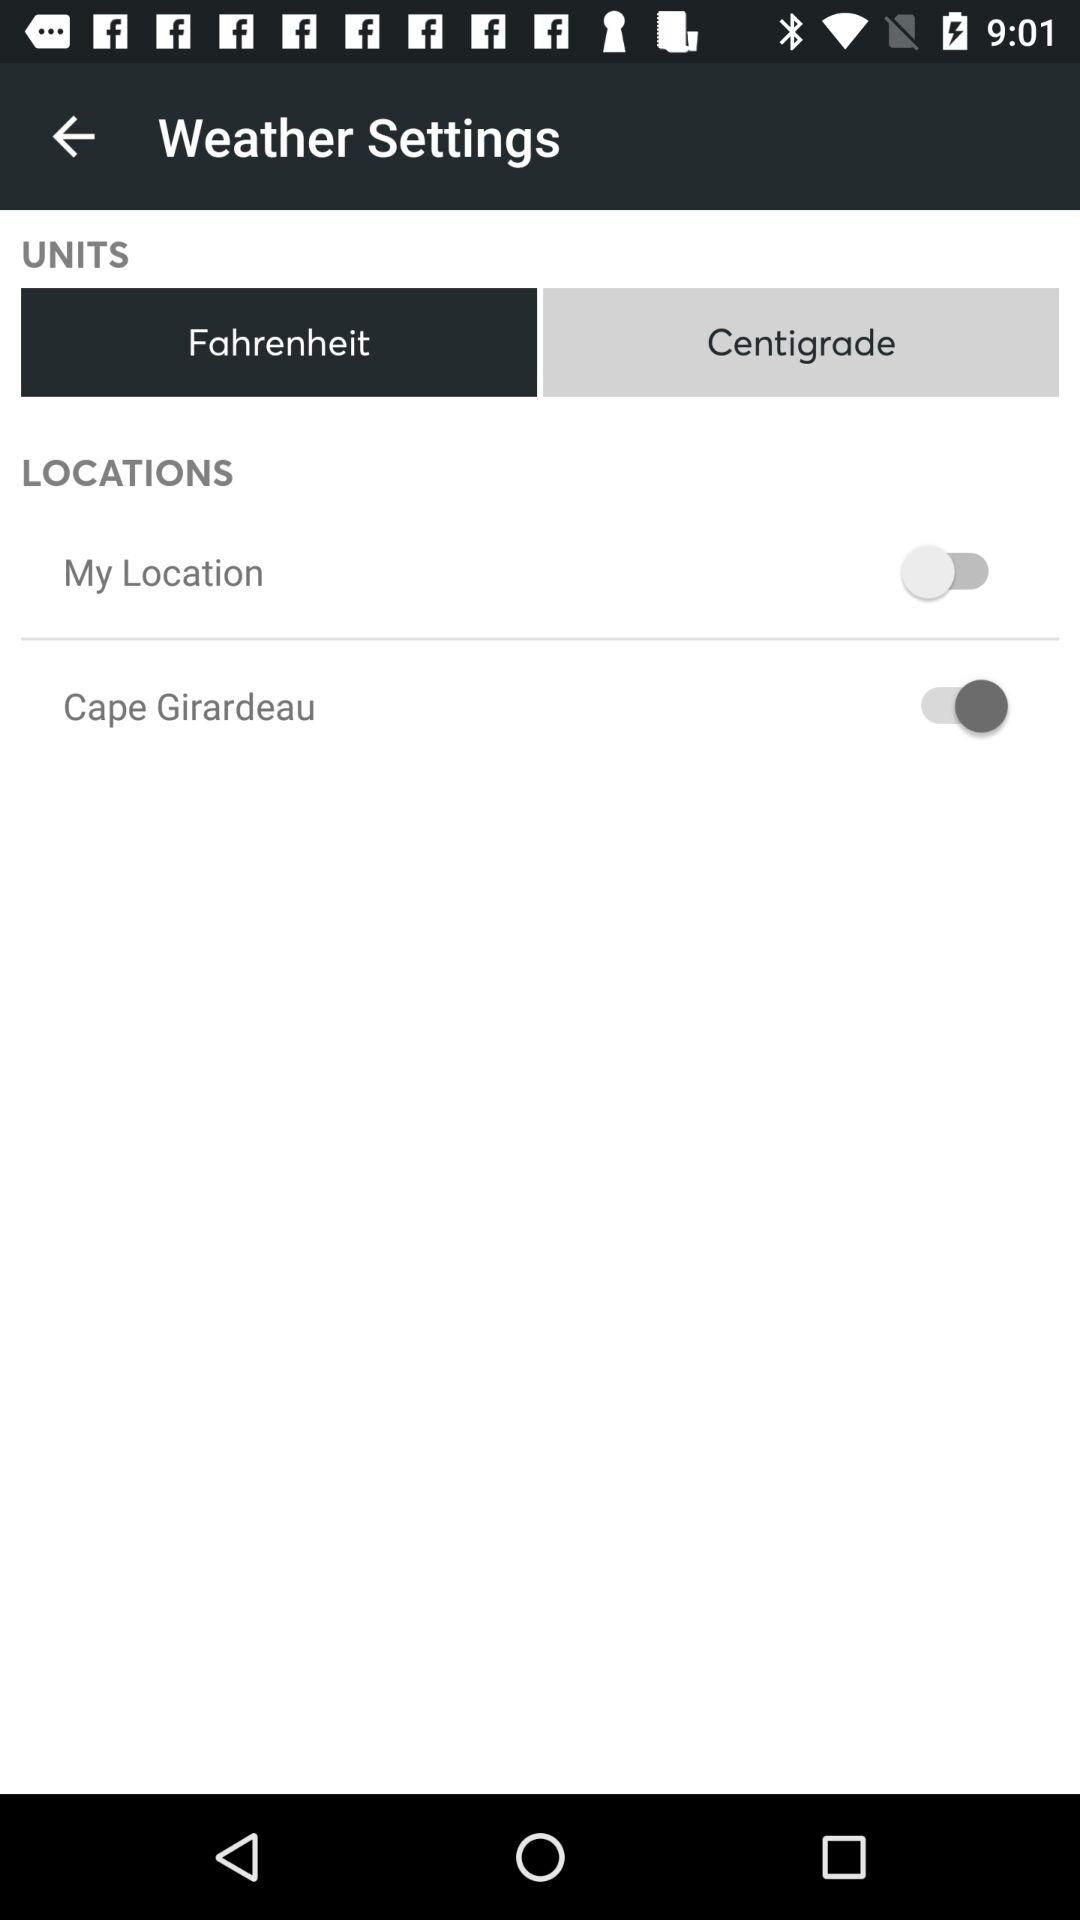How many locations are displayed that are not my location?
Answer the question using a single word or phrase. 1 